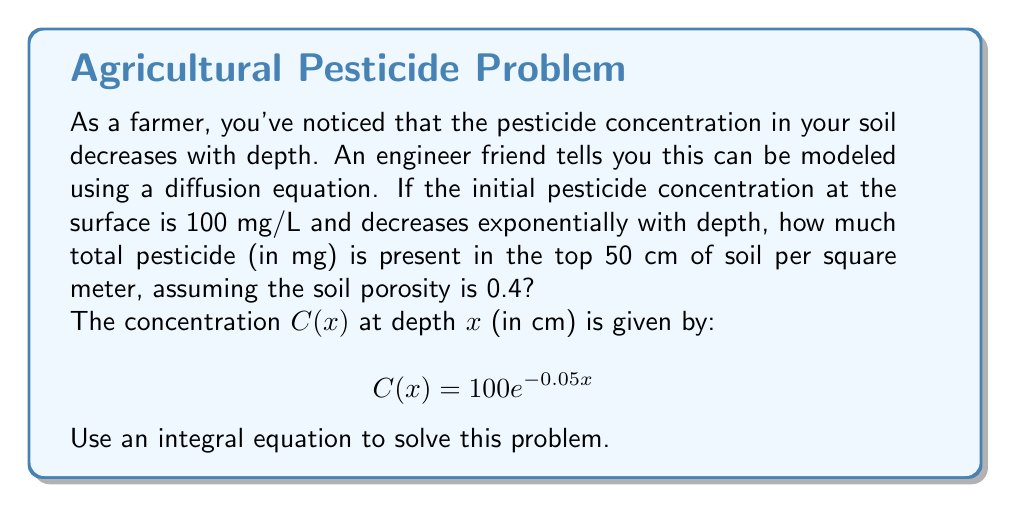Teach me how to tackle this problem. Let's approach this step-by-step:

1) The total amount of pesticide is found by integrating the concentration over the depth, considering the soil porosity:

   $$\text{Total Pesticide} = \text{Porosity} \times \text{Area} \times \int_0^{50} C(x) dx$$

2) We're given that the porosity is 0.4 and we're considering 1 square meter of surface area.

3) Substituting the concentration function:

   $$\text{Total Pesticide} = 0.4 \times 1 \times \int_0^{50} 100e^{-0.05x} dx$$

4) Simplifying:

   $$\text{Total Pesticide} = 40 \int_0^{50} e^{-0.05x} dx$$

5) To solve this integral, we use the rule $\int e^{ax} dx = \frac{1}{a}e^{ax} + C$:

   $$\text{Total Pesticide} = 40 \left[ -\frac{1}{0.05}e^{-0.05x} \right]_0^{50}$$

6) Evaluating the bounds:

   $$\text{Total Pesticide} = 40 \left( -\frac{1}{0.05}e^{-0.05(50)} + \frac{1}{0.05}e^{-0.05(0)} \right)$$

7) Simplifying:

   $$\text{Total Pesticide} = 40 \left( -20e^{-2.5} + 20 \right)$$

8) Calculating:

   $$\text{Total Pesticide} \approx 40 (-1.6487 + 20) \approx 733.25 \text{ mg}$$
Answer: 733.25 mg 